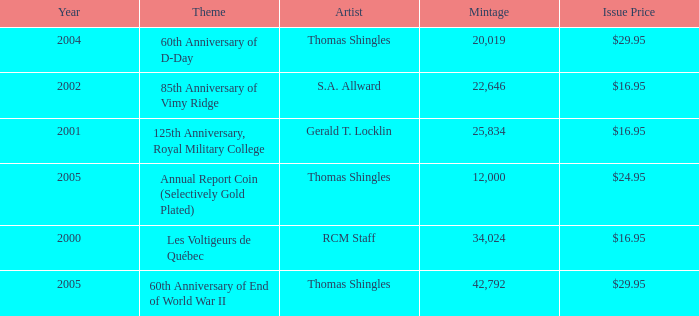What year was S.A. Allward's theme that had an issue price of $16.95 released? 2002.0. 